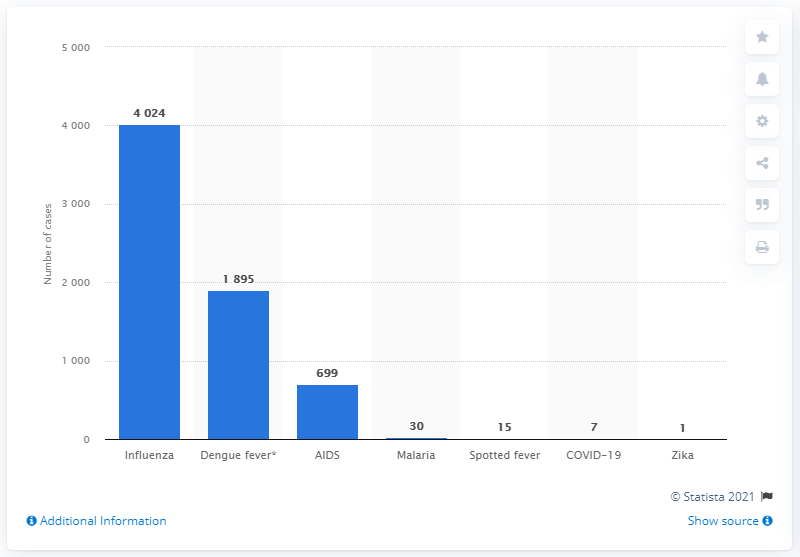Point out several critical features in this image. As of March 7, 2020, there were 7 cases of COVID-19. The new coronavirus has been named COVID-19. 